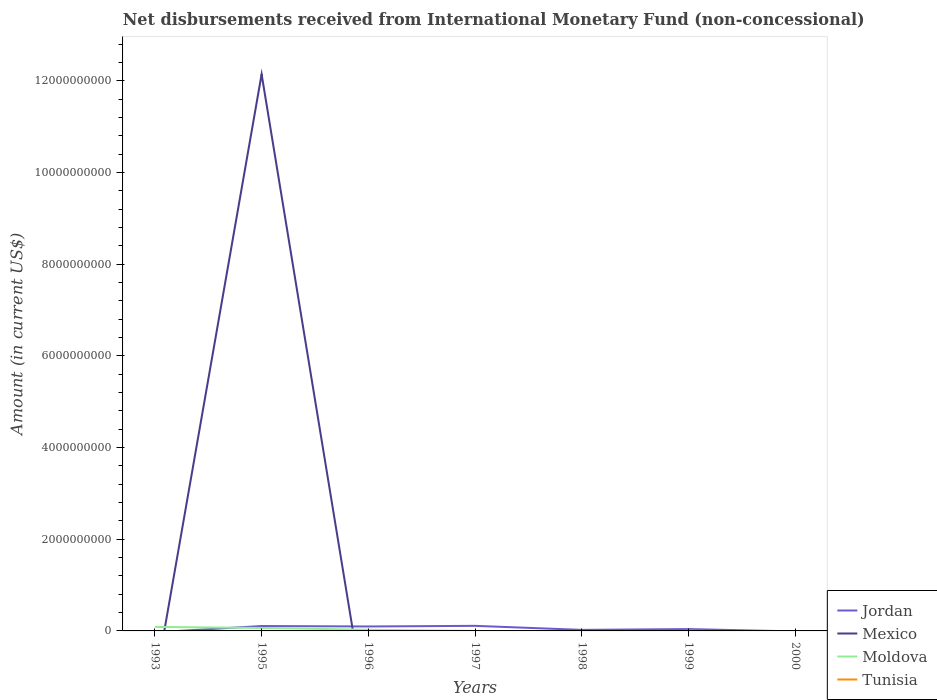How many different coloured lines are there?
Keep it short and to the point. 3. Across all years, what is the maximum amount of disbursements received from International Monetary Fund in Tunisia?
Provide a succinct answer. 0. What is the total amount of disbursements received from International Monetary Fund in Jordan in the graph?
Your response must be concise. -1.36e+07. What is the difference between the highest and the second highest amount of disbursements received from International Monetary Fund in Jordan?
Offer a terse response. 1.11e+08. Is the amount of disbursements received from International Monetary Fund in Tunisia strictly greater than the amount of disbursements received from International Monetary Fund in Jordan over the years?
Your response must be concise. No. How many years are there in the graph?
Your answer should be compact. 7. How many legend labels are there?
Offer a very short reply. 4. How are the legend labels stacked?
Your answer should be very brief. Vertical. What is the title of the graph?
Offer a terse response. Net disbursements received from International Monetary Fund (non-concessional). Does "Least developed countries" appear as one of the legend labels in the graph?
Offer a very short reply. No. What is the label or title of the X-axis?
Your answer should be very brief. Years. What is the label or title of the Y-axis?
Make the answer very short. Amount (in current US$). What is the Amount (in current US$) in Jordan in 1993?
Provide a short and direct response. 0. What is the Amount (in current US$) of Moldova in 1993?
Offer a terse response. 8.80e+07. What is the Amount (in current US$) in Jordan in 1995?
Your answer should be very brief. 1.07e+08. What is the Amount (in current US$) in Mexico in 1995?
Give a very brief answer. 1.21e+1. What is the Amount (in current US$) of Moldova in 1995?
Offer a terse response. 6.43e+07. What is the Amount (in current US$) in Jordan in 1996?
Ensure brevity in your answer.  9.72e+07. What is the Amount (in current US$) in Mexico in 1996?
Provide a short and direct response. 0. What is the Amount (in current US$) of Moldova in 1996?
Offer a very short reply. 2.53e+07. What is the Amount (in current US$) of Jordan in 1997?
Your answer should be very brief. 1.11e+08. What is the Amount (in current US$) in Mexico in 1997?
Provide a succinct answer. 0. What is the Amount (in current US$) of Moldova in 1997?
Make the answer very short. 6.01e+05. What is the Amount (in current US$) in Jordan in 1998?
Offer a very short reply. 2.28e+07. What is the Amount (in current US$) of Moldova in 1998?
Offer a terse response. 0. What is the Amount (in current US$) in Jordan in 1999?
Provide a short and direct response. 4.03e+07. What is the Amount (in current US$) of Moldova in 1999?
Give a very brief answer. 2.92e+06. What is the Amount (in current US$) in Jordan in 2000?
Offer a terse response. 0. What is the Amount (in current US$) in Mexico in 2000?
Ensure brevity in your answer.  0. What is the Amount (in current US$) of Moldova in 2000?
Make the answer very short. 0. What is the Amount (in current US$) in Tunisia in 2000?
Your answer should be very brief. 0. Across all years, what is the maximum Amount (in current US$) in Jordan?
Provide a succinct answer. 1.11e+08. Across all years, what is the maximum Amount (in current US$) of Mexico?
Your response must be concise. 1.21e+1. Across all years, what is the maximum Amount (in current US$) in Moldova?
Your answer should be compact. 8.80e+07. What is the total Amount (in current US$) of Jordan in the graph?
Your response must be concise. 3.78e+08. What is the total Amount (in current US$) in Mexico in the graph?
Give a very brief answer. 1.21e+1. What is the total Amount (in current US$) of Moldova in the graph?
Your response must be concise. 1.81e+08. What is the total Amount (in current US$) of Tunisia in the graph?
Your answer should be very brief. 0. What is the difference between the Amount (in current US$) in Moldova in 1993 and that in 1995?
Offer a terse response. 2.36e+07. What is the difference between the Amount (in current US$) in Moldova in 1993 and that in 1996?
Ensure brevity in your answer.  6.27e+07. What is the difference between the Amount (in current US$) of Moldova in 1993 and that in 1997?
Your answer should be compact. 8.74e+07. What is the difference between the Amount (in current US$) of Moldova in 1993 and that in 1999?
Your response must be concise. 8.51e+07. What is the difference between the Amount (in current US$) in Jordan in 1995 and that in 1996?
Your answer should be compact. 9.45e+06. What is the difference between the Amount (in current US$) in Moldova in 1995 and that in 1996?
Provide a short and direct response. 3.90e+07. What is the difference between the Amount (in current US$) of Jordan in 1995 and that in 1997?
Keep it short and to the point. -4.11e+06. What is the difference between the Amount (in current US$) of Moldova in 1995 and that in 1997?
Offer a terse response. 6.37e+07. What is the difference between the Amount (in current US$) in Jordan in 1995 and that in 1998?
Ensure brevity in your answer.  8.38e+07. What is the difference between the Amount (in current US$) of Jordan in 1995 and that in 1999?
Provide a succinct answer. 6.64e+07. What is the difference between the Amount (in current US$) of Moldova in 1995 and that in 1999?
Ensure brevity in your answer.  6.14e+07. What is the difference between the Amount (in current US$) in Jordan in 1996 and that in 1997?
Provide a short and direct response. -1.36e+07. What is the difference between the Amount (in current US$) in Moldova in 1996 and that in 1997?
Offer a very short reply. 2.47e+07. What is the difference between the Amount (in current US$) in Jordan in 1996 and that in 1998?
Keep it short and to the point. 7.43e+07. What is the difference between the Amount (in current US$) of Jordan in 1996 and that in 1999?
Ensure brevity in your answer.  5.69e+07. What is the difference between the Amount (in current US$) of Moldova in 1996 and that in 1999?
Offer a very short reply. 2.24e+07. What is the difference between the Amount (in current US$) in Jordan in 1997 and that in 1998?
Keep it short and to the point. 8.79e+07. What is the difference between the Amount (in current US$) of Jordan in 1997 and that in 1999?
Make the answer very short. 7.05e+07. What is the difference between the Amount (in current US$) in Moldova in 1997 and that in 1999?
Give a very brief answer. -2.32e+06. What is the difference between the Amount (in current US$) in Jordan in 1998 and that in 1999?
Offer a very short reply. -1.74e+07. What is the difference between the Amount (in current US$) in Jordan in 1995 and the Amount (in current US$) in Moldova in 1996?
Make the answer very short. 8.13e+07. What is the difference between the Amount (in current US$) in Mexico in 1995 and the Amount (in current US$) in Moldova in 1996?
Keep it short and to the point. 1.21e+1. What is the difference between the Amount (in current US$) of Jordan in 1995 and the Amount (in current US$) of Moldova in 1997?
Your answer should be very brief. 1.06e+08. What is the difference between the Amount (in current US$) of Mexico in 1995 and the Amount (in current US$) of Moldova in 1997?
Your response must be concise. 1.21e+1. What is the difference between the Amount (in current US$) in Jordan in 1995 and the Amount (in current US$) in Moldova in 1999?
Offer a very short reply. 1.04e+08. What is the difference between the Amount (in current US$) in Mexico in 1995 and the Amount (in current US$) in Moldova in 1999?
Give a very brief answer. 1.21e+1. What is the difference between the Amount (in current US$) of Jordan in 1996 and the Amount (in current US$) of Moldova in 1997?
Make the answer very short. 9.66e+07. What is the difference between the Amount (in current US$) in Jordan in 1996 and the Amount (in current US$) in Moldova in 1999?
Offer a terse response. 9.43e+07. What is the difference between the Amount (in current US$) in Jordan in 1997 and the Amount (in current US$) in Moldova in 1999?
Ensure brevity in your answer.  1.08e+08. What is the difference between the Amount (in current US$) of Jordan in 1998 and the Amount (in current US$) of Moldova in 1999?
Give a very brief answer. 1.99e+07. What is the average Amount (in current US$) of Jordan per year?
Ensure brevity in your answer.  5.40e+07. What is the average Amount (in current US$) of Mexico per year?
Give a very brief answer. 1.73e+09. What is the average Amount (in current US$) of Moldova per year?
Your answer should be compact. 2.59e+07. In the year 1995, what is the difference between the Amount (in current US$) of Jordan and Amount (in current US$) of Mexico?
Keep it short and to the point. -1.20e+1. In the year 1995, what is the difference between the Amount (in current US$) of Jordan and Amount (in current US$) of Moldova?
Ensure brevity in your answer.  4.23e+07. In the year 1995, what is the difference between the Amount (in current US$) of Mexico and Amount (in current US$) of Moldova?
Provide a succinct answer. 1.21e+1. In the year 1996, what is the difference between the Amount (in current US$) of Jordan and Amount (in current US$) of Moldova?
Your answer should be compact. 7.19e+07. In the year 1997, what is the difference between the Amount (in current US$) of Jordan and Amount (in current US$) of Moldova?
Ensure brevity in your answer.  1.10e+08. In the year 1999, what is the difference between the Amount (in current US$) of Jordan and Amount (in current US$) of Moldova?
Provide a short and direct response. 3.74e+07. What is the ratio of the Amount (in current US$) in Moldova in 1993 to that in 1995?
Your response must be concise. 1.37. What is the ratio of the Amount (in current US$) in Moldova in 1993 to that in 1996?
Your answer should be very brief. 3.48. What is the ratio of the Amount (in current US$) in Moldova in 1993 to that in 1997?
Give a very brief answer. 146.38. What is the ratio of the Amount (in current US$) in Moldova in 1993 to that in 1999?
Offer a very short reply. 30.11. What is the ratio of the Amount (in current US$) of Jordan in 1995 to that in 1996?
Make the answer very short. 1.1. What is the ratio of the Amount (in current US$) of Moldova in 1995 to that in 1996?
Provide a succinct answer. 2.54. What is the ratio of the Amount (in current US$) in Jordan in 1995 to that in 1997?
Provide a succinct answer. 0.96. What is the ratio of the Amount (in current US$) of Moldova in 1995 to that in 1997?
Make the answer very short. 107.04. What is the ratio of the Amount (in current US$) of Jordan in 1995 to that in 1998?
Offer a very short reply. 4.67. What is the ratio of the Amount (in current US$) in Jordan in 1995 to that in 1999?
Your answer should be compact. 2.65. What is the ratio of the Amount (in current US$) in Moldova in 1995 to that in 1999?
Offer a terse response. 22.02. What is the ratio of the Amount (in current US$) in Jordan in 1996 to that in 1997?
Your answer should be very brief. 0.88. What is the ratio of the Amount (in current US$) of Moldova in 1996 to that in 1997?
Your response must be concise. 42.12. What is the ratio of the Amount (in current US$) in Jordan in 1996 to that in 1998?
Make the answer very short. 4.26. What is the ratio of the Amount (in current US$) in Jordan in 1996 to that in 1999?
Your answer should be compact. 2.41. What is the ratio of the Amount (in current US$) in Moldova in 1996 to that in 1999?
Offer a very short reply. 8.66. What is the ratio of the Amount (in current US$) in Jordan in 1997 to that in 1998?
Provide a succinct answer. 4.85. What is the ratio of the Amount (in current US$) in Jordan in 1997 to that in 1999?
Your answer should be compact. 2.75. What is the ratio of the Amount (in current US$) in Moldova in 1997 to that in 1999?
Provide a short and direct response. 0.21. What is the ratio of the Amount (in current US$) of Jordan in 1998 to that in 1999?
Provide a short and direct response. 0.57. What is the difference between the highest and the second highest Amount (in current US$) in Jordan?
Ensure brevity in your answer.  4.11e+06. What is the difference between the highest and the second highest Amount (in current US$) of Moldova?
Give a very brief answer. 2.36e+07. What is the difference between the highest and the lowest Amount (in current US$) of Jordan?
Give a very brief answer. 1.11e+08. What is the difference between the highest and the lowest Amount (in current US$) in Mexico?
Provide a succinct answer. 1.21e+1. What is the difference between the highest and the lowest Amount (in current US$) of Moldova?
Keep it short and to the point. 8.80e+07. 